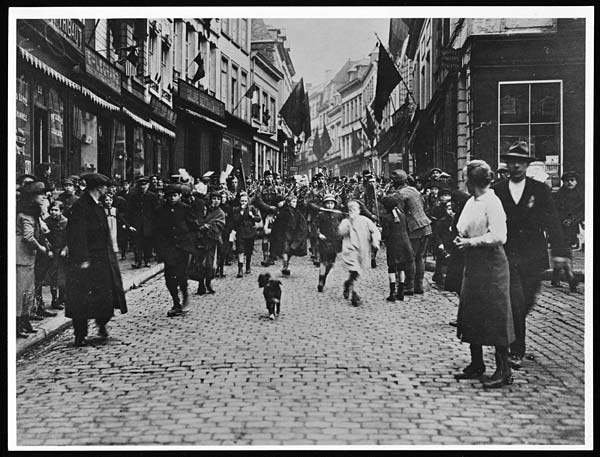<image>What flag is in the background? It is ambiguous what flag is in the background. They could be 'black flag', 'american', 'german', 'nazi', or 'uk'. Why are the people in the middle running? It is unknown why the people in the middle are running. They could be part of a parade or they might be trying to get out of the way. What flag is in the background? I don't know what flag is in the background. It is difficult to tell from the given options. Why are the people in the middle running? The reason why the people in the middle are running is ambiguous. It can be seen as being chased or trying to dodge the parade. 